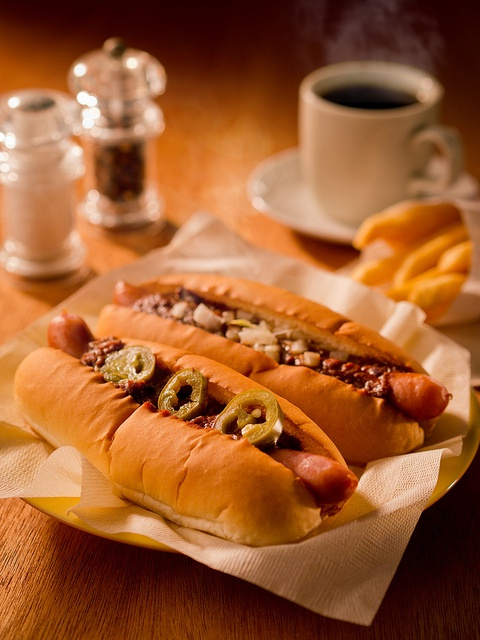Describe the objects in this image and their specific colors. I can see dining table in black, maroon, brown, and orange tones, hot dog in black, orange, and red tones, hot dog in black, red, brown, tan, and maroon tones, and cup in black, gray, tan, and brown tones in this image. 